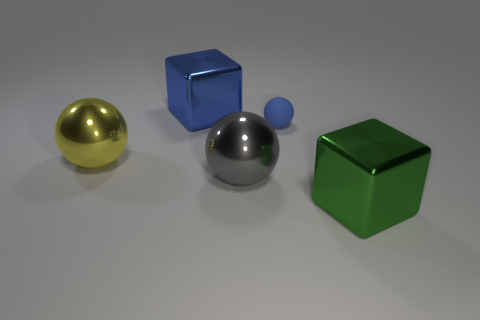There is a object on the left side of the big blue block; what is its material?
Keep it short and to the point. Metal. The large thing that is the same color as the matte ball is what shape?
Make the answer very short. Cube. Are there any big gray spheres that have the same material as the yellow object?
Offer a terse response. Yes. What size is the rubber ball?
Make the answer very short. Small. How many gray things are big balls or large rubber cylinders?
Make the answer very short. 1. What number of big blue objects are the same shape as the small blue rubber object?
Your answer should be very brief. 0. How many brown blocks have the same size as the green metal object?
Provide a short and direct response. 0. There is a yellow thing that is the same shape as the big gray metallic thing; what is its material?
Provide a succinct answer. Metal. What color is the cube that is behind the big gray shiny ball?
Your answer should be compact. Blue. Is the number of large metallic things that are behind the gray thing greater than the number of tiny purple things?
Ensure brevity in your answer.  Yes. 